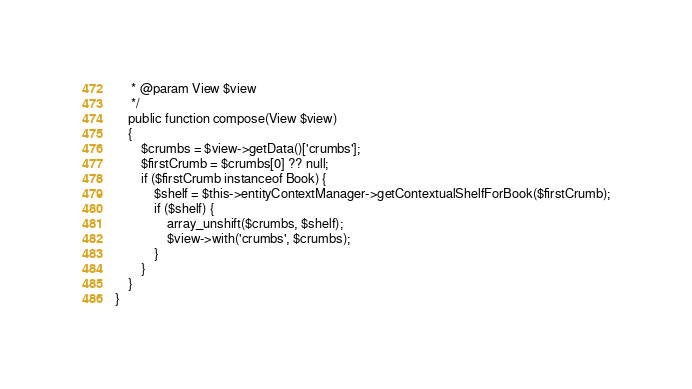Convert code to text. <code><loc_0><loc_0><loc_500><loc_500><_PHP_>     * @param View $view
     */
    public function compose(View $view)
    {
        $crumbs = $view->getData()['crumbs'];
        $firstCrumb = $crumbs[0] ?? null;
        if ($firstCrumb instanceof Book) {
            $shelf = $this->entityContextManager->getContextualShelfForBook($firstCrumb);
            if ($shelf) {
                array_unshift($crumbs, $shelf);
                $view->with('crumbs', $crumbs);
            }
        }
    }
}
</code> 